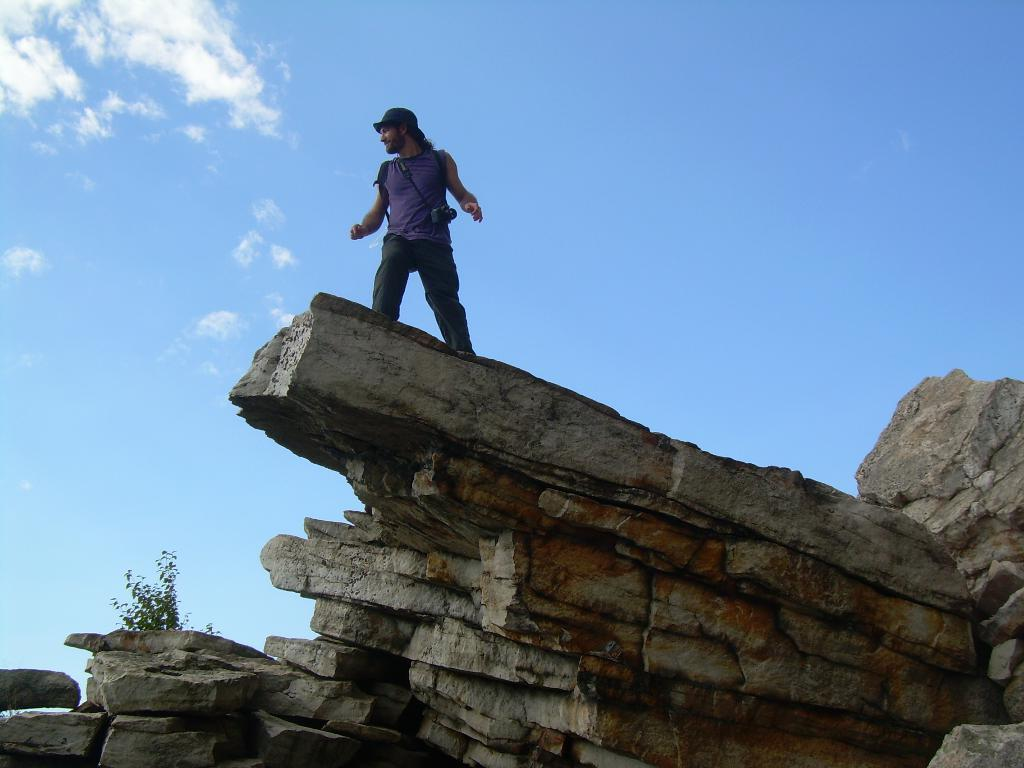What is the main subject of the image? There is a person standing in the image. What is the person wearing in the image? The person is wearing a camera in the image. What type of natural elements can be seen in the image? There are rocks and a plant visible in the image. What can be seen in the background of the image? The sky with clouds is visible in the background of the image. How many passengers are visible in the image? There are no passengers visible in the image, as it only features a person standing. What type of watch is the stranger wearing in the image? There is no stranger in the image, and therefore no watch can be observed. 